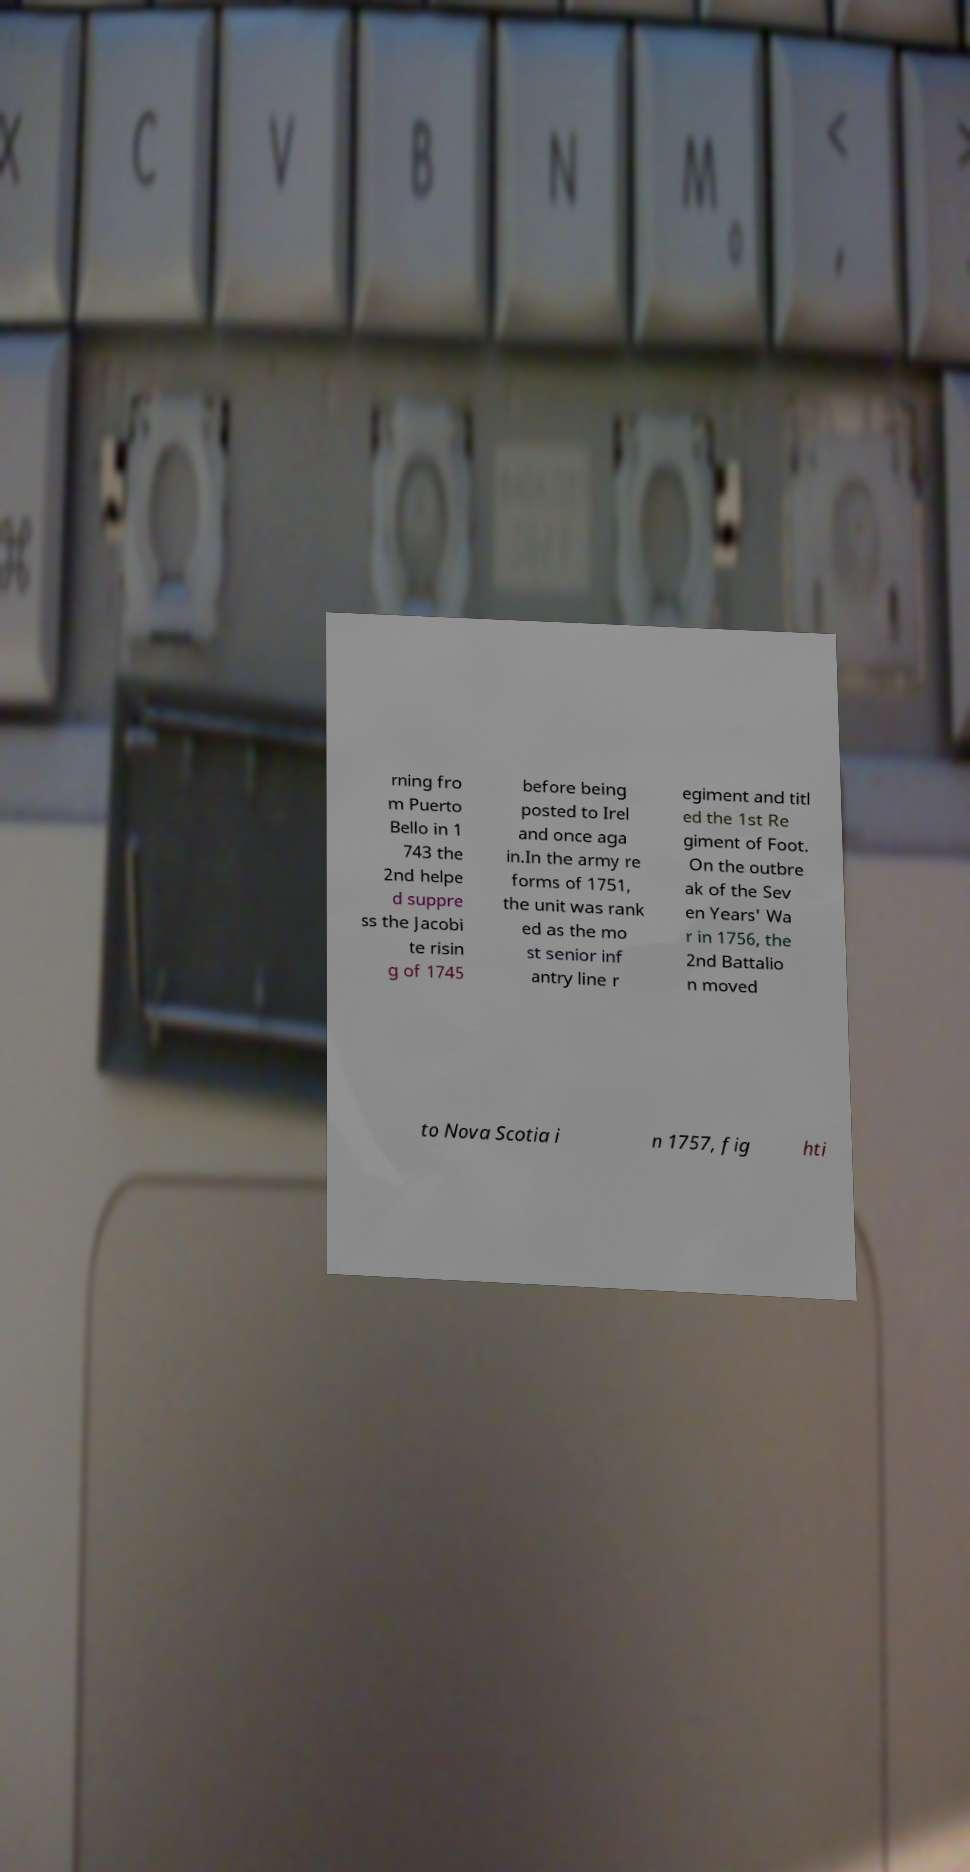Can you read and provide the text displayed in the image?This photo seems to have some interesting text. Can you extract and type it out for me? rning fro m Puerto Bello in 1 743 the 2nd helpe d suppre ss the Jacobi te risin g of 1745 before being posted to Irel and once aga in.In the army re forms of 1751, the unit was rank ed as the mo st senior inf antry line r egiment and titl ed the 1st Re giment of Foot. On the outbre ak of the Sev en Years' Wa r in 1756, the 2nd Battalio n moved to Nova Scotia i n 1757, fig hti 